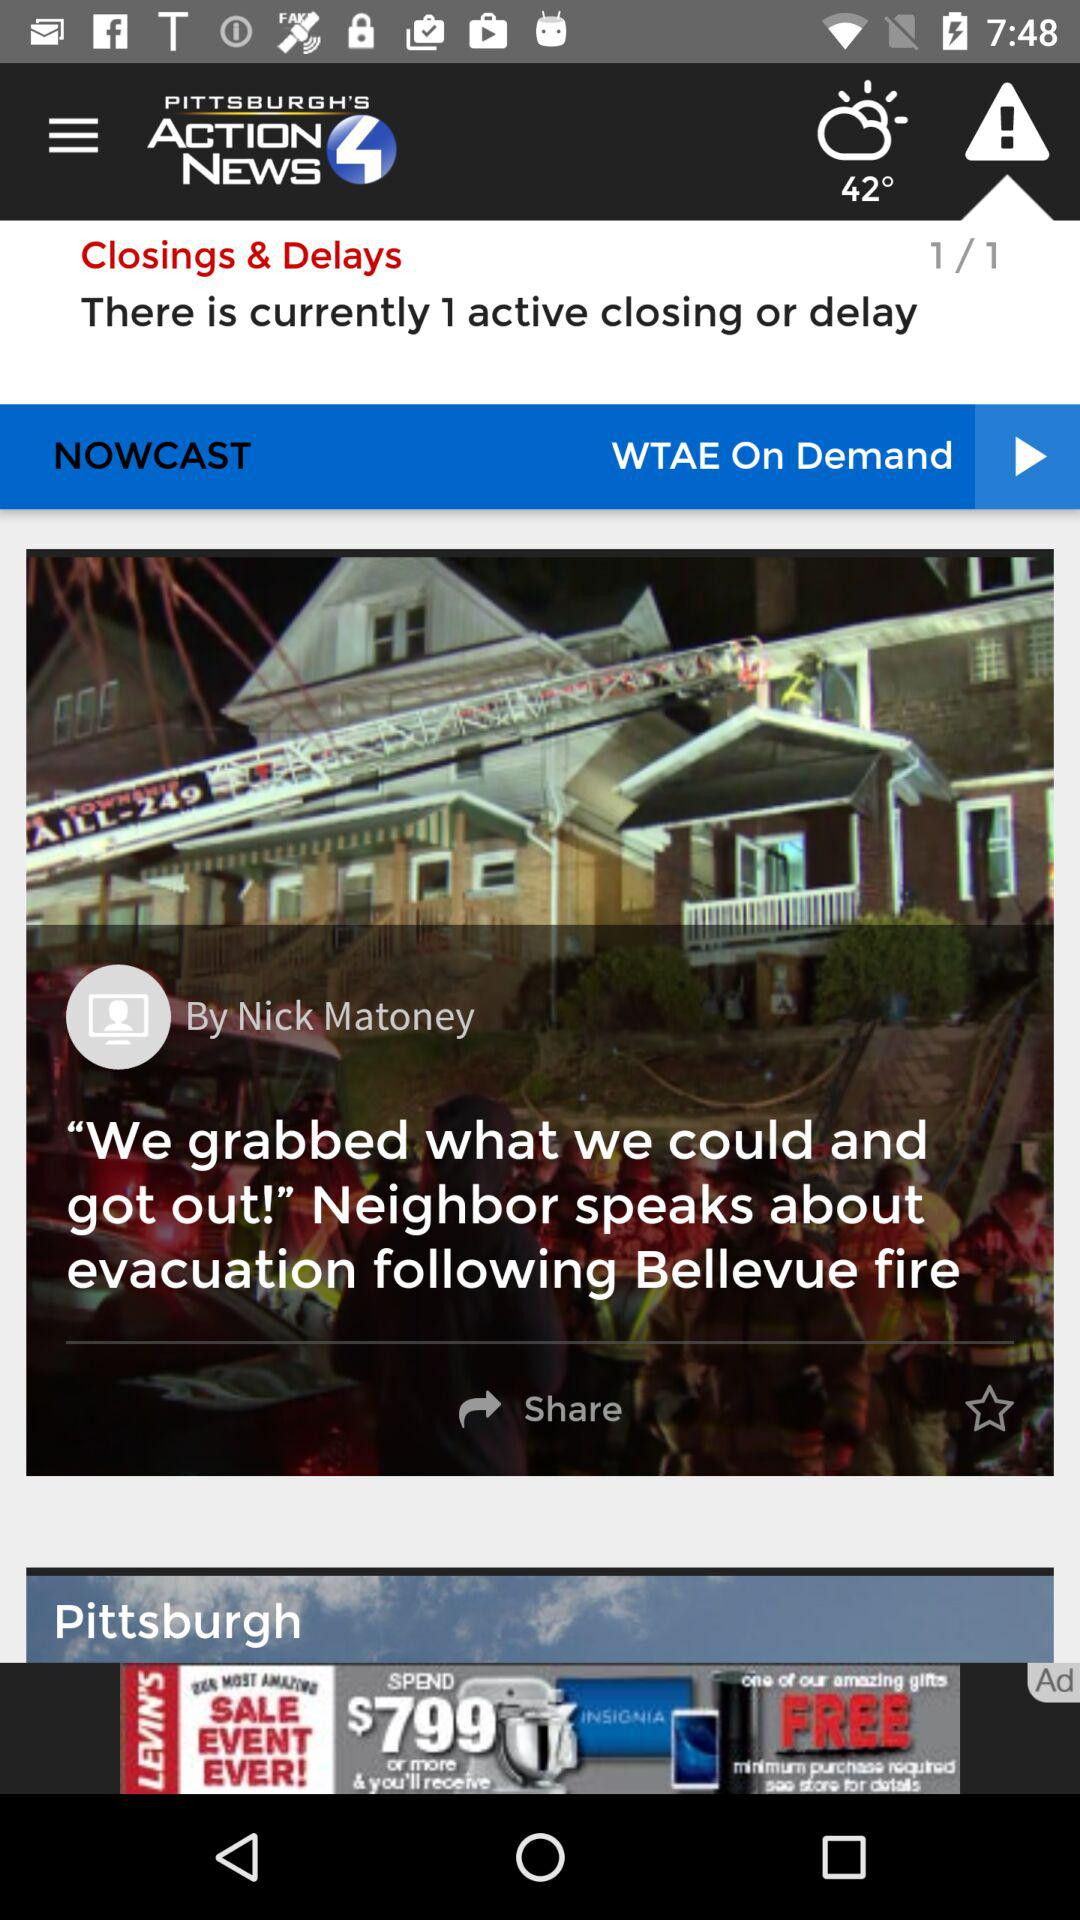How many closings and delays are there?
Answer the question using a single word or phrase. 1 